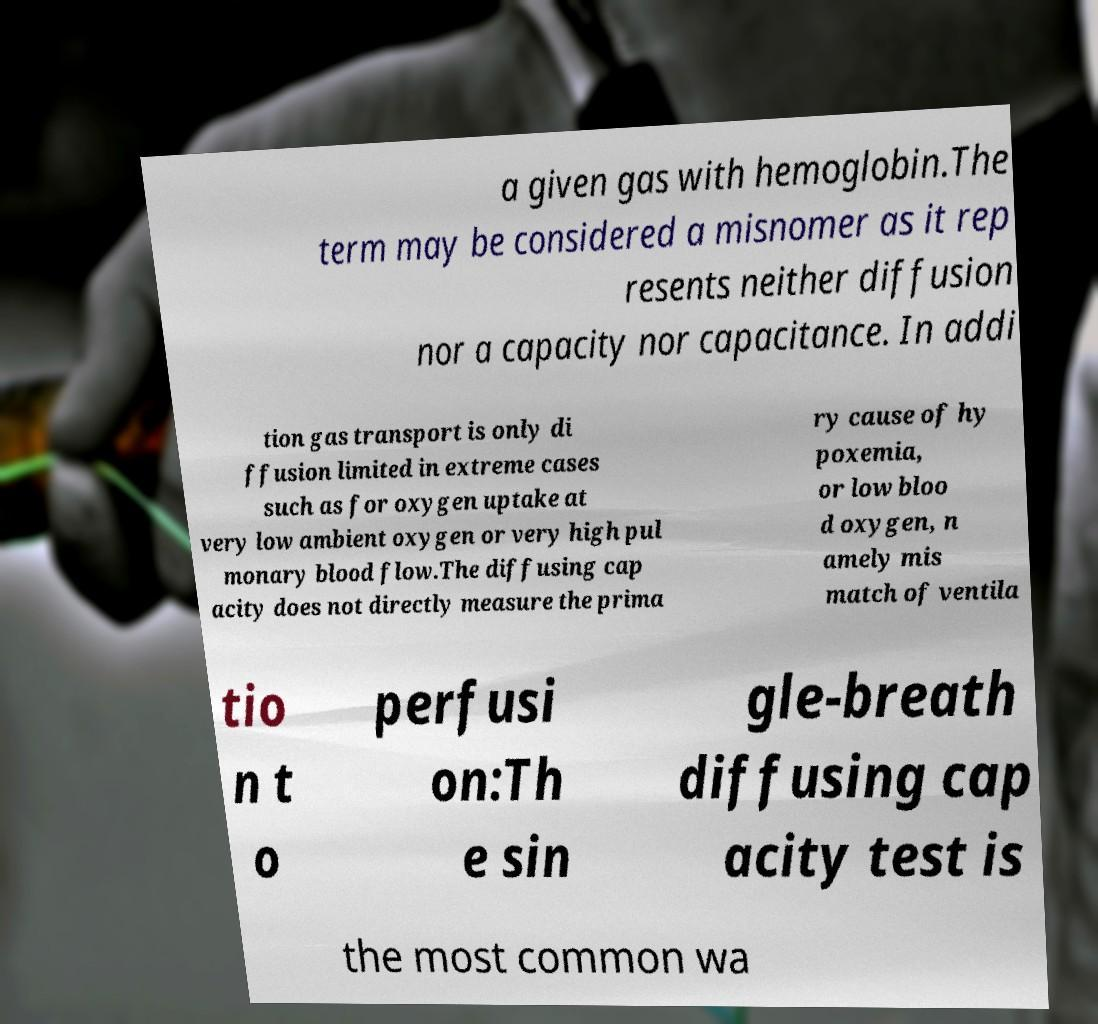Could you extract and type out the text from this image? a given gas with hemoglobin.The term may be considered a misnomer as it rep resents neither diffusion nor a capacity nor capacitance. In addi tion gas transport is only di ffusion limited in extreme cases such as for oxygen uptake at very low ambient oxygen or very high pul monary blood flow.The diffusing cap acity does not directly measure the prima ry cause of hy poxemia, or low bloo d oxygen, n amely mis match of ventila tio n t o perfusi on:Th e sin gle-breath diffusing cap acity test is the most common wa 